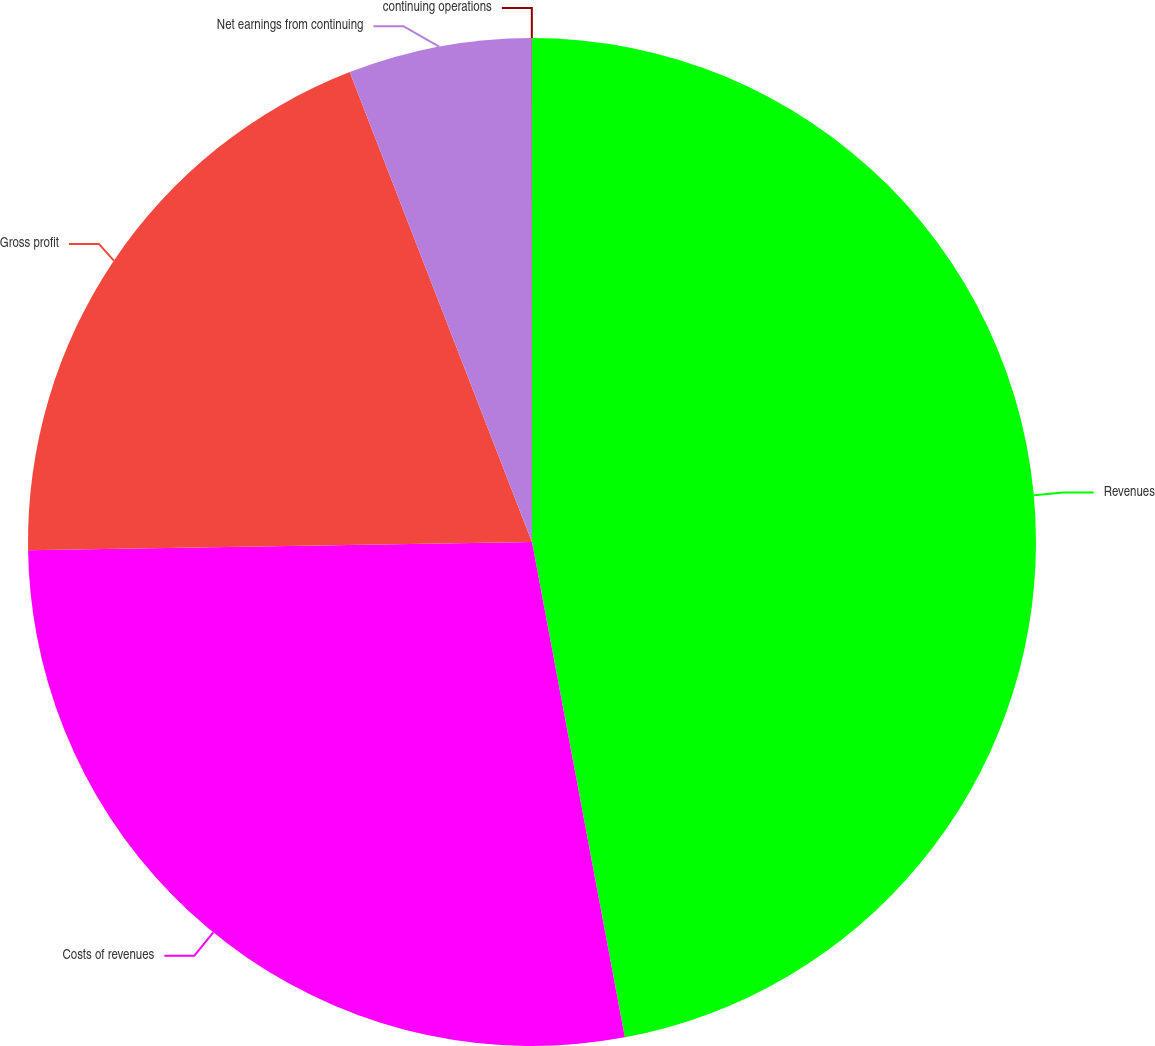Convert chart to OTSL. <chart><loc_0><loc_0><loc_500><loc_500><pie_chart><fcel>Revenues<fcel>Costs of revenues<fcel>Gross profit<fcel>Net earnings from continuing<fcel>continuing operations<nl><fcel>47.05%<fcel>27.69%<fcel>19.37%<fcel>5.88%<fcel>0.01%<nl></chart> 